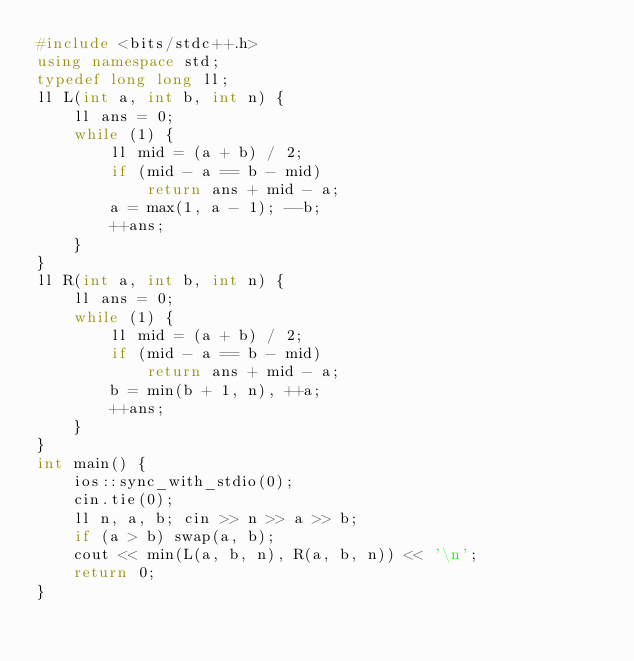Convert code to text. <code><loc_0><loc_0><loc_500><loc_500><_C++_>#include <bits/stdc++.h>
using namespace std;
typedef long long ll;
ll L(int a, int b, int n) {
    ll ans = 0;
    while (1) {
        ll mid = (a + b) / 2;
        if (mid - a == b - mid)
            return ans + mid - a;
        a = max(1, a - 1); --b;
        ++ans;
    }
}
ll R(int a, int b, int n) {
    ll ans = 0;
    while (1) {
        ll mid = (a + b) / 2;
        if (mid - a == b - mid)
            return ans + mid - a;
        b = min(b + 1, n), ++a;
        ++ans;
    }
}
int main() {
    ios::sync_with_stdio(0);
    cin.tie(0);
    ll n, a, b; cin >> n >> a >> b;
    if (a > b) swap(a, b);
    cout << min(L(a, b, n), R(a, b, n)) << '\n';
    return 0;
}</code> 